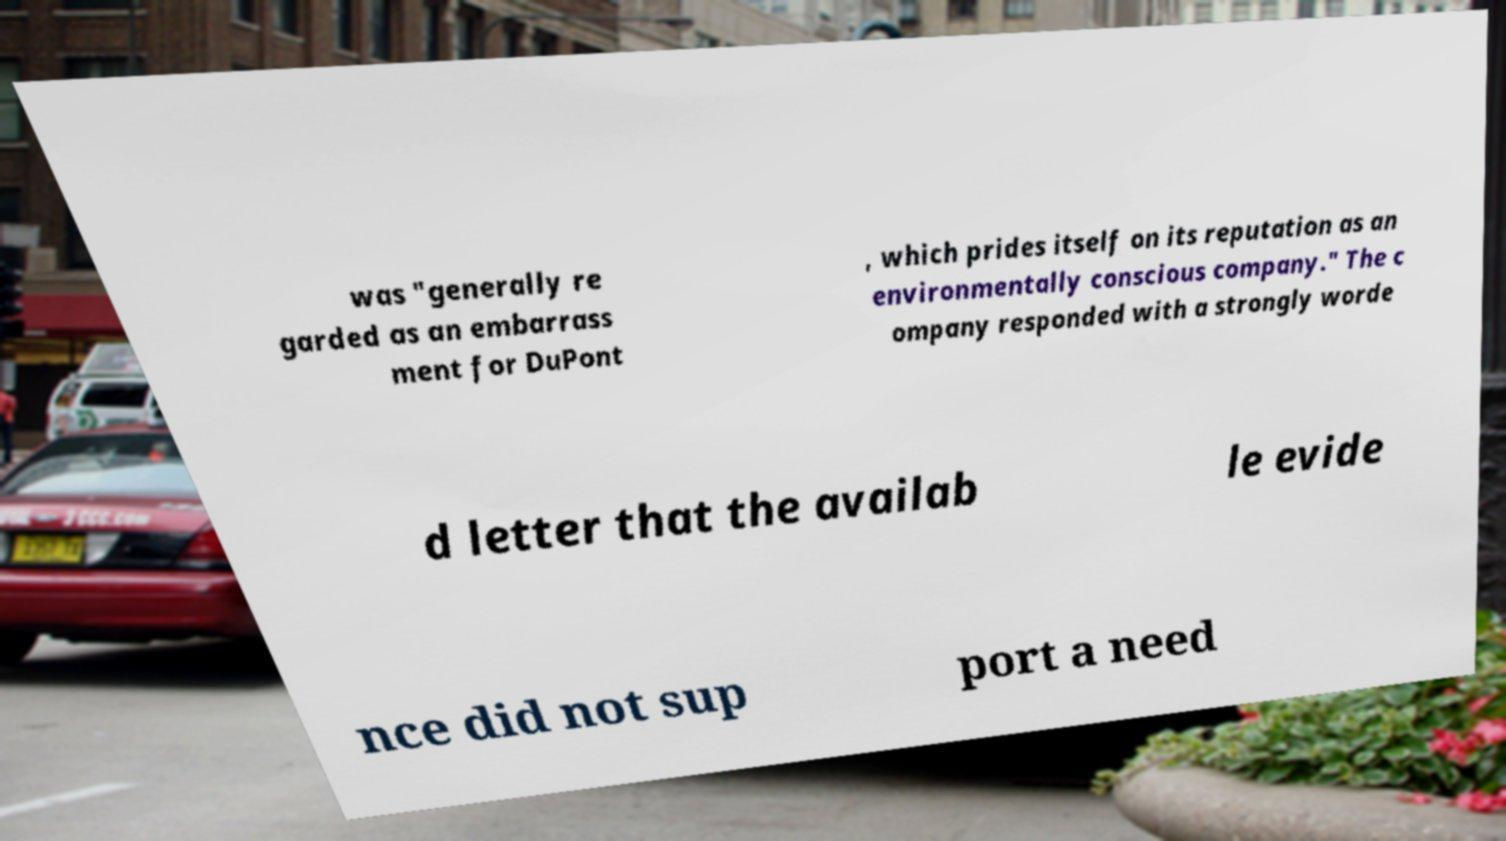Please identify and transcribe the text found in this image. was "generally re garded as an embarrass ment for DuPont , which prides itself on its reputation as an environmentally conscious company." The c ompany responded with a strongly worde d letter that the availab le evide nce did not sup port a need 